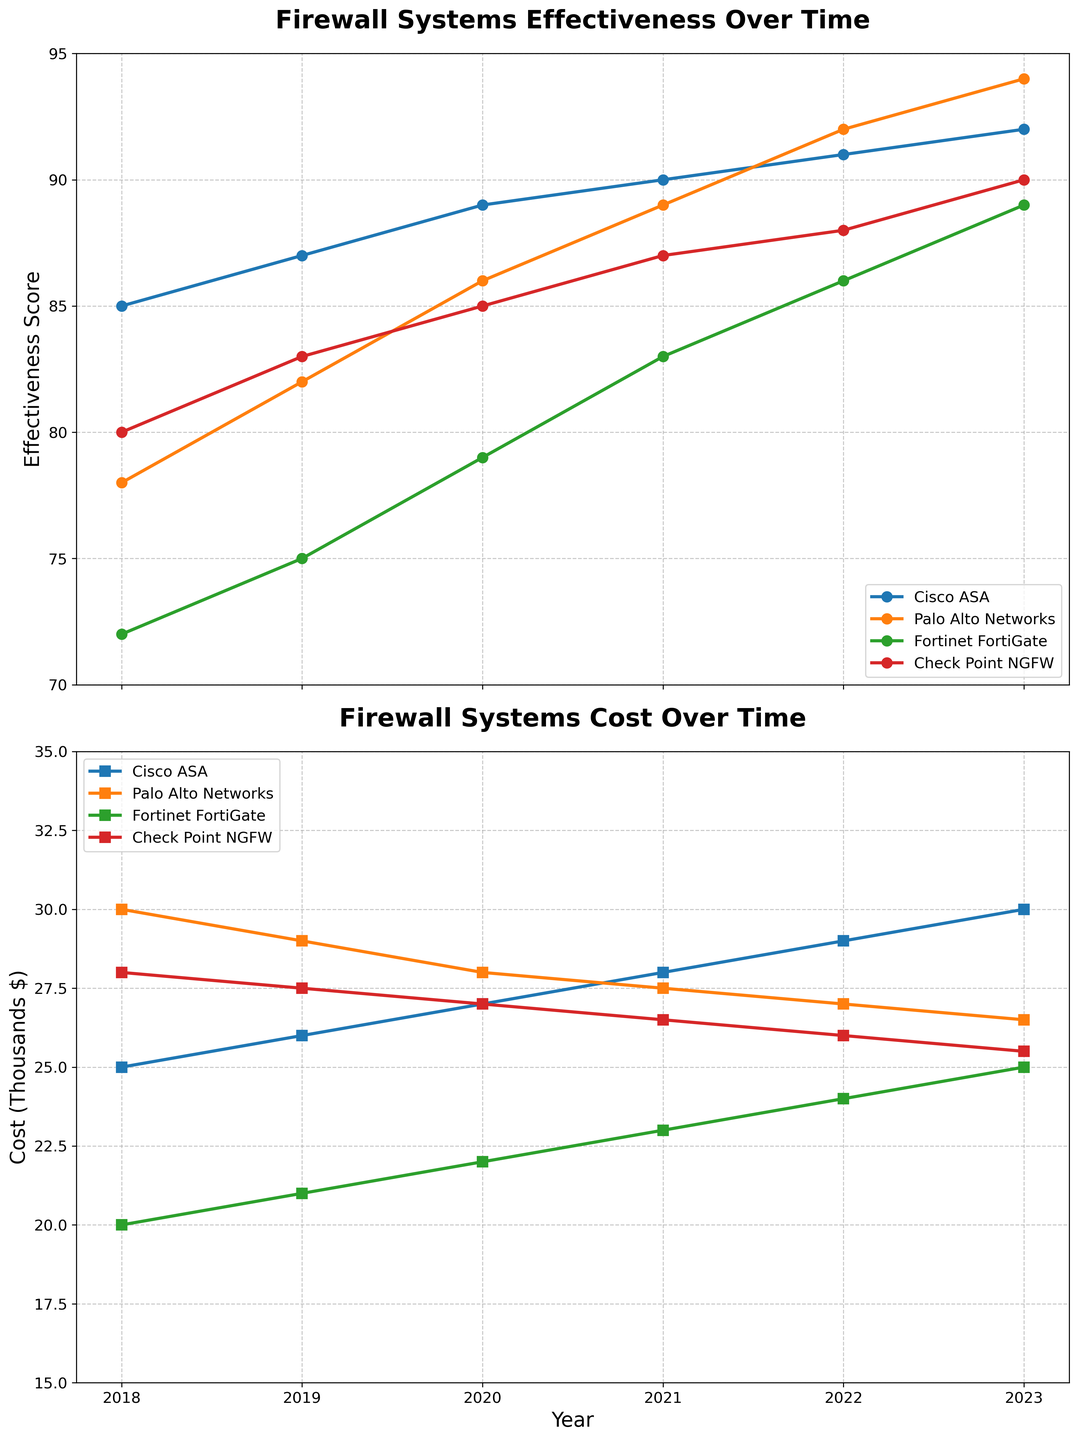What's the title of the first subplot? The title of the first subplot is located above the plot area and should describe the contents of the graph.
Answer: Firewall Systems Effectiveness Over Time How has the effectiveness of Cisco ASA changed from 2018 to 2023? To determine the change in effectiveness, look at the data points for Cisco ASA on the y-axis for the years 2018 and 2023.
Answer: Increased from 85 to 92 Which firewall system had the highest effectiveness score in 2019? Compare the effectiveness scores for all firewall systems in 2019 and identify the highest value.
Answer: Palo Alto Networks Which firewall system experienced the most significant increase in effectiveness between 2018 and 2023? Calculate the difference in effectiveness for each system between 2018 and 2023 and identify the system with the largest increase.
Answer: Palo Alto Networks What is the cost trend for Check Point NGFW from 2018 to 2023? Examine the data points for Check Point NGFW on the cost plot and observe the changes over the years.
Answer: Decreased from $28,000 to $25,500 Which year did Fortinet FortiGate surpass $25,000 in cost? Look at the data points for Fortinet FortiGate in the cost plot and identify the first year where the cost is greater than $25,000.
Answer: 2022 By how much did the effectiveness of Palo Alto Networks improve from 2021 to 2023? Subtract the effectiveness score of Palo Alto Networks in 2021 from its score in 2023.
Answer: 5 points Which firewall system shows the least price change over the years? Calculate the cost difference from 2018 to 2023 for each system and identify the smallest change.
Answer: Palo Alto Networks Compare the costs of Cisco ASA and the effectiveness of Fortinet FortiGate in the year 2020. Identify and compare the cost of Cisco ASA and the effectiveness of Fortinet FortiGate in 2020 from their respective plots.
Answer: $27,000 vs. 79 Which firewall system had a cost lower than $27,000 in 2021? Check the cost data for 2021 and identify the systems with costs below $27,000.
Answer: Fortinet FortiGate and Check Point NGFW 